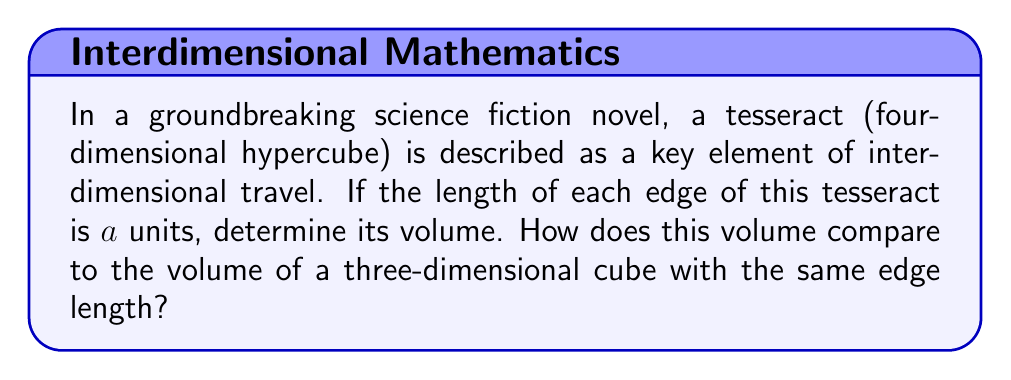Can you solve this math problem? To solve this problem, we need to understand how dimensions affect volume calculations:

1) For a 1-dimensional line segment of length $a$, the "volume" (length) is $a$.

2) For a 2-dimensional square with side length $a$, the area is $a^2$.

3) For a 3-dimensional cube with edge length $a$, the volume is $a^3$.

4) Following this pattern, we can deduce that for an n-dimensional hypercube (of which a tesseract is a 4-dimensional example), the "volume" would be $a^n$.

Therefore, for a tesseract with edge length $a$, the volume is:

$$ V_{tesseract} = a^4 $$

To compare this with a 3-dimensional cube:

$$ V_{cube} = a^3 $$

The ratio of these volumes is:

$$ \frac{V_{tesseract}}{V_{cube}} = \frac{a^4}{a^3} = a $$

This means that the volume of a tesseract is $a$ times larger than the volume of a cube with the same edge length.

This concept of higher-dimensional spaces and their properties is often explored in science fiction, particularly in stories involving interdimensional travel or non-Euclidean geometries. The idea of a tesseract, while mathematically definable, challenges our 3-dimensional perception and provides rich ground for imaginative storytelling.
Answer: The volume of a tesseract with edge length $a$ is $a^4$ cubic units. This volume is $a$ times larger than the volume of a three-dimensional cube with the same edge length. 